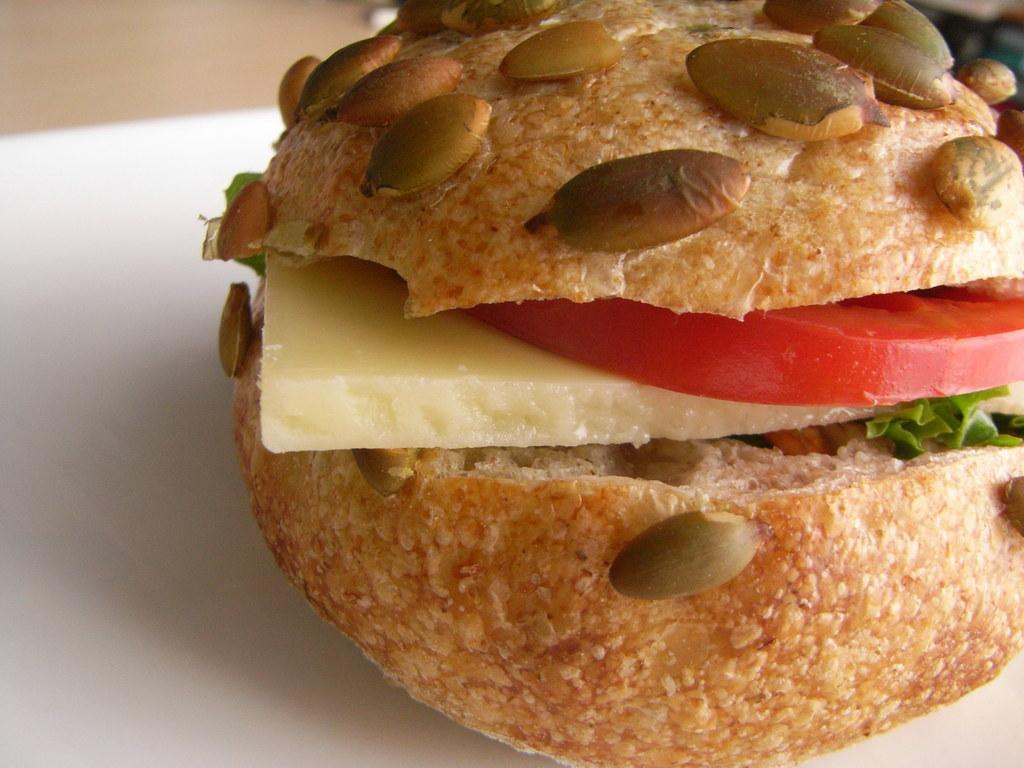What type of food is visible in the image? There is a sandwich in the image. What is on top of the sandwich? The sandwich has veggies on it. Where is the sandwich located? The sandwich is on a table. What type of pollution can be seen coming from the tank in the image? There is no tank or pollution present in the image; it only features a sandwich with veggies on it. 